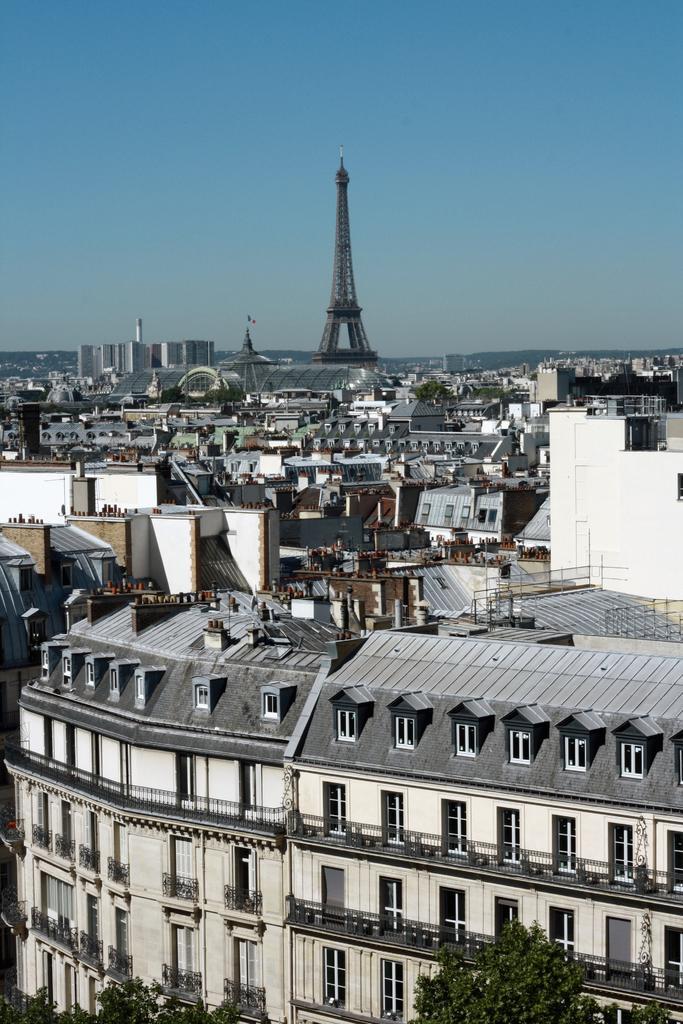Describe this image in one or two sentences. In this image there are few buildings, tower in the middle, at the top there is the sky, at the bottom there are some trees visible. 